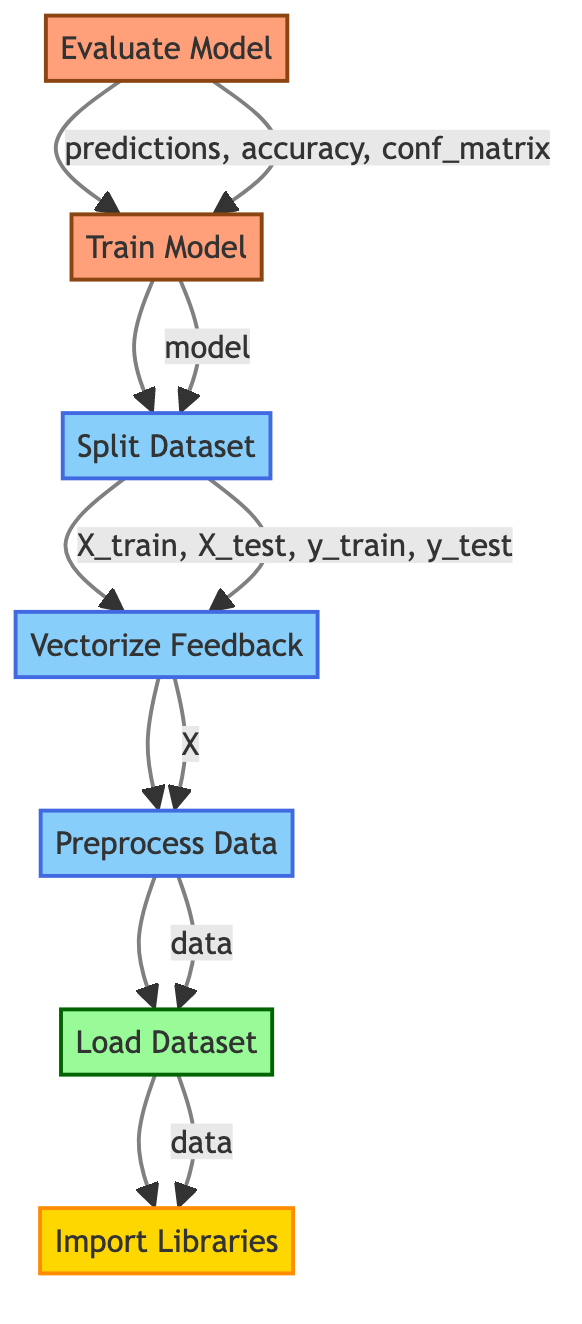What is the first step in this flowchart? The flowchart begins with the "Import Libraries" node, which is the bottommost step.
Answer: Import Libraries What node comes after "Load Dataset"? The next node after "Load Dataset" is "Preprocess Data", which can be seen directly above it.
Answer: Preprocess Data How many total nodes are in the flowchart? By counting each node represented in the flowchart, there are seven nodes total, starting from "Import Libraries" to "Evaluate Model".
Answer: Seven What does the "Evaluate Model" node output? The "Evaluate Model" node's outputs are labeled; they include predictions, accuracy, and confusion matrix, corresponding to the results generated from the model evaluation.
Answer: Predictions, accuracy, confusion matrix Which two processes occur after "Vectorize Feedback"? The two subsequent processes are "Split Dataset" and "Evaluate Model," where "Split Dataset" follows directly after it, and "Evaluate Model" comes after "Train Model".
Answer: Split Dataset, Evaluate Model What type of model is used in this flowchart? The flowchart specifies the usage of the Multinomial Naive Bayes model, as indicated in the "Train Model" node.
Answer: Multinomial Naive Bayes What relationship is shown between "Train Model" and "Split Dataset"? The flowchart indicates that "Train Model" uses outputs from "Split Dataset" as its inputs, namely X_train, X_test, y_train, and y_test that are derived after splitting the dataset.
Answer: Model uses outputs as inputs Which step involves handling missing data? The "Preprocess Data" node is responsible for handling missing data by executing the statement to drop any rows with null values in the dataset.
Answer: Preprocess Data 